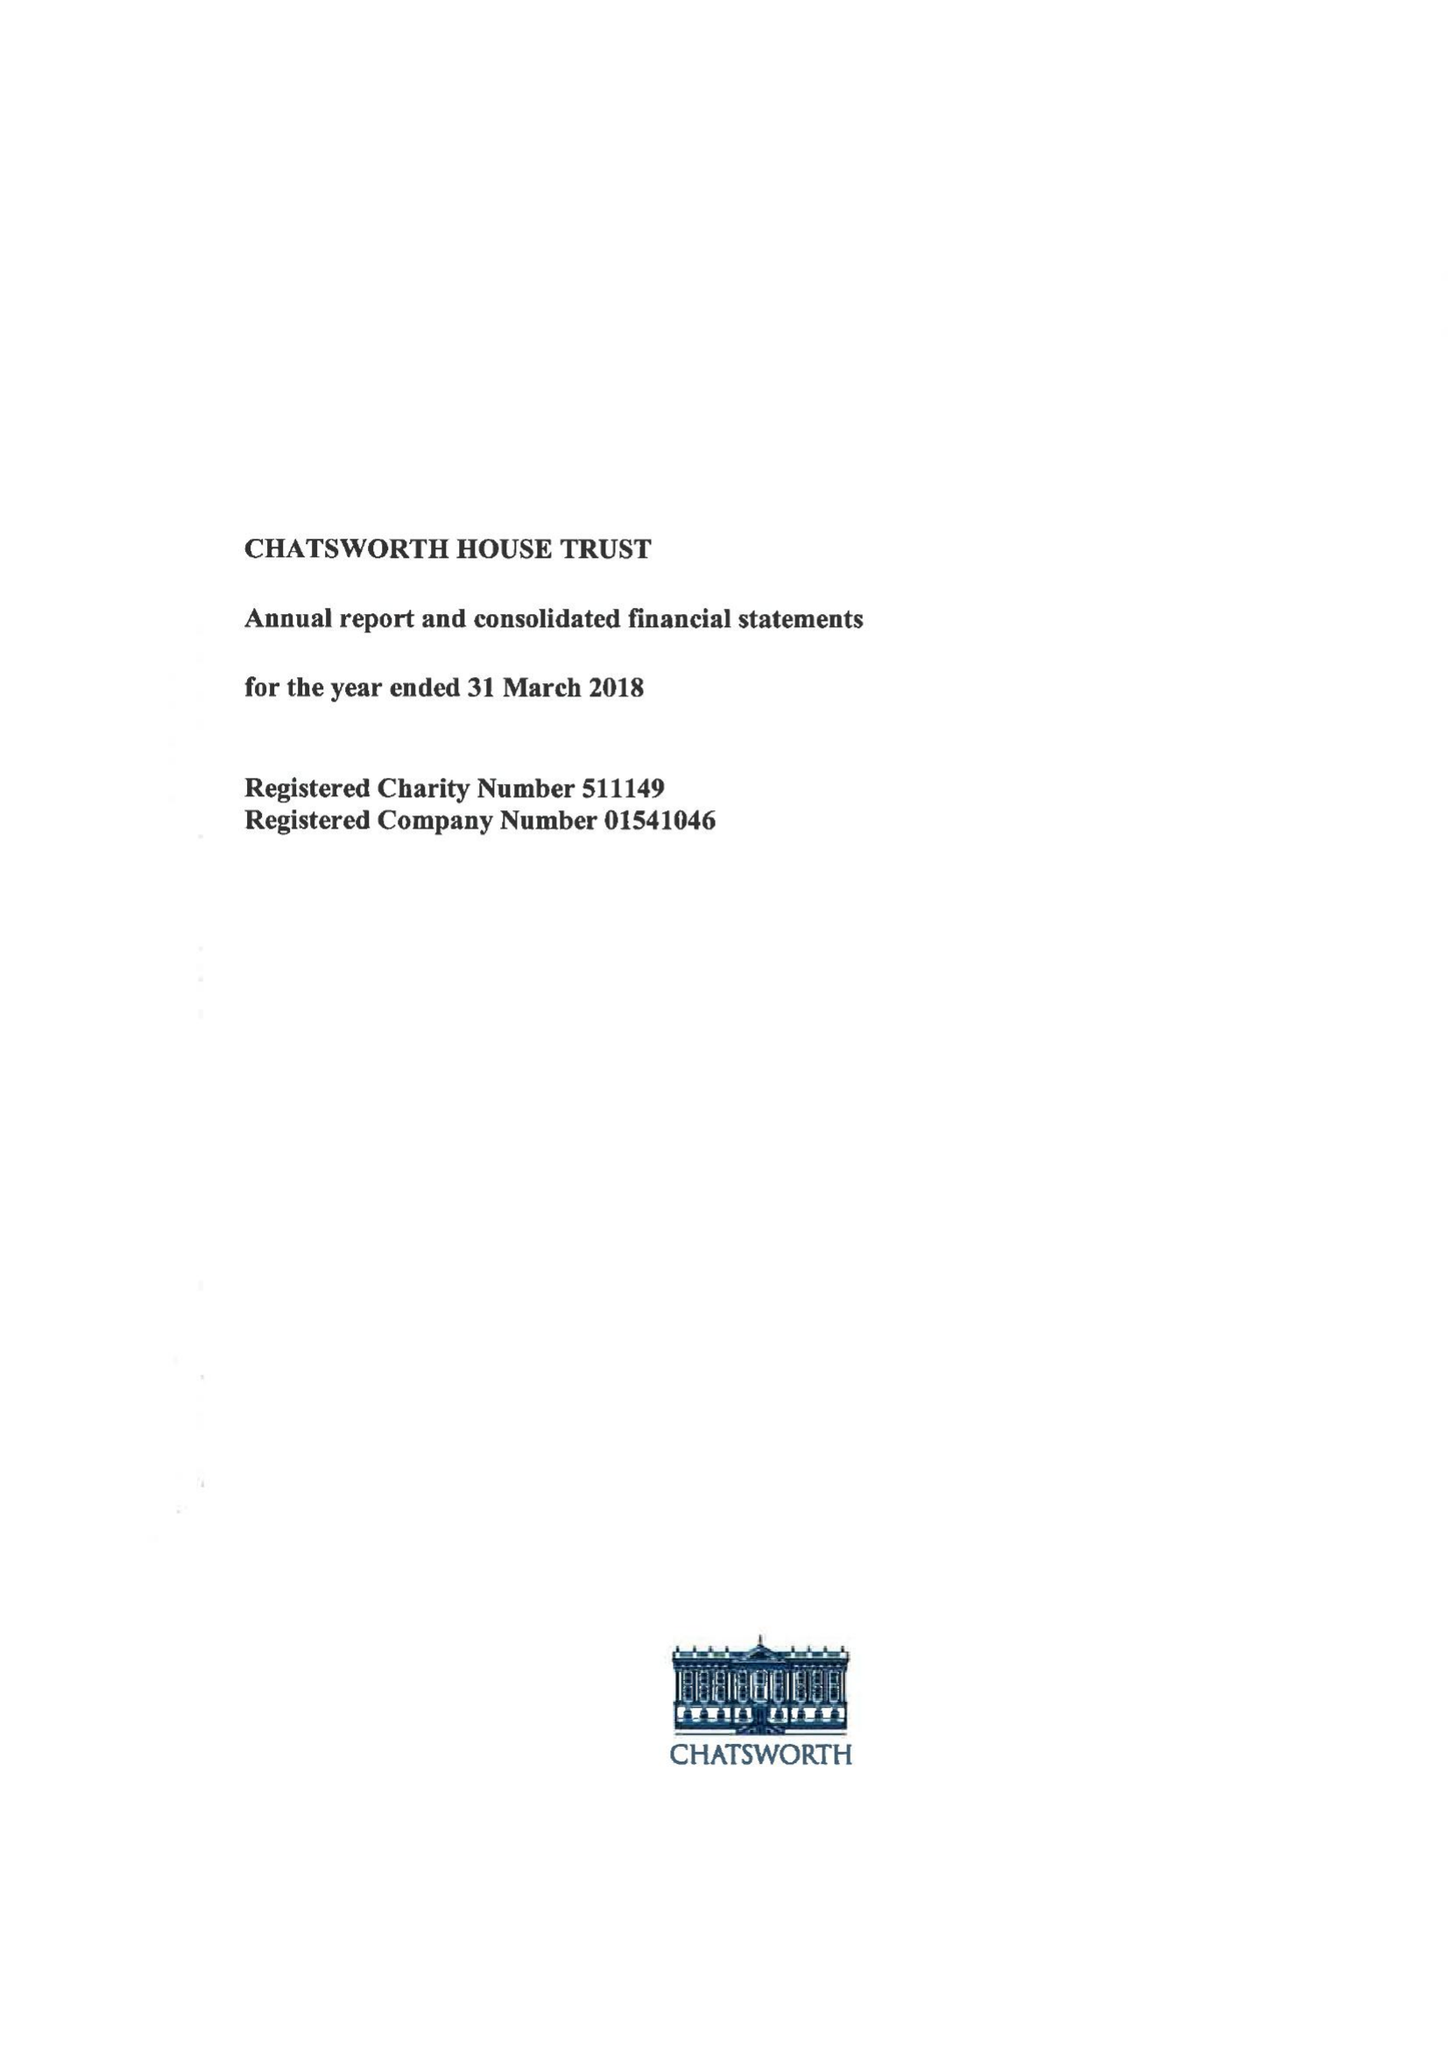What is the value for the income_annually_in_british_pounds?
Answer the question using a single word or phrase. 14991000.00 